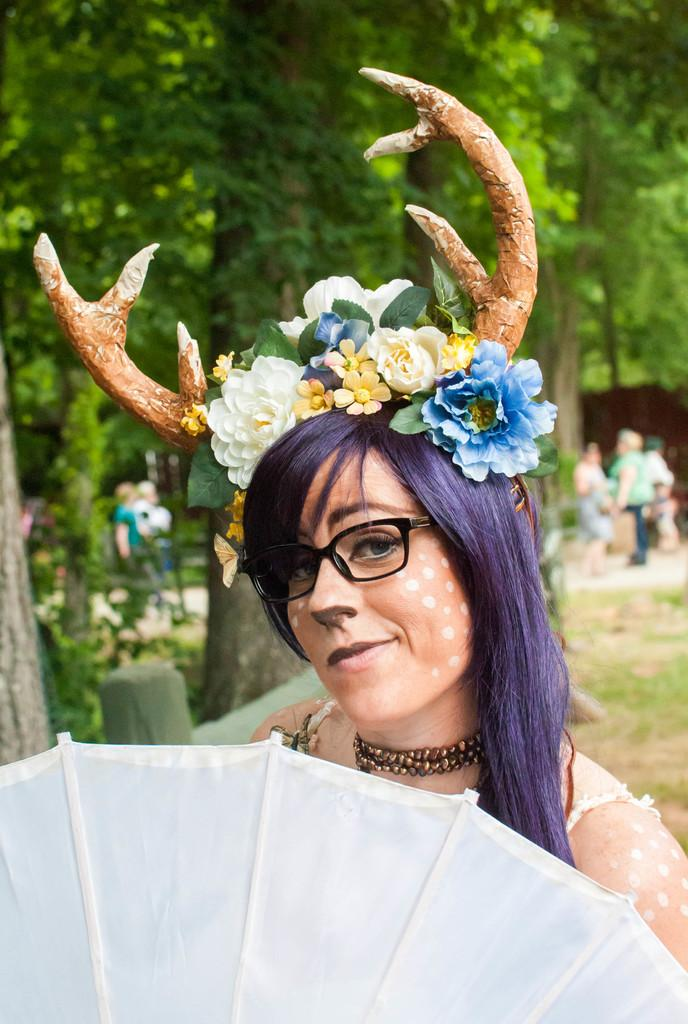Who is the main subject in the image? There is a woman in the image. What is the woman holding in the image? The woman is holding an umbrella. Are there any other people visible in the image? Yes, there are people standing behind the woman. What can be seen in the background of the image? There are trees in the background of the image. Can you tell me how many islands are visible in the image? There are no islands visible in the image; it features a woman holding an umbrella with people and trees in the background. 